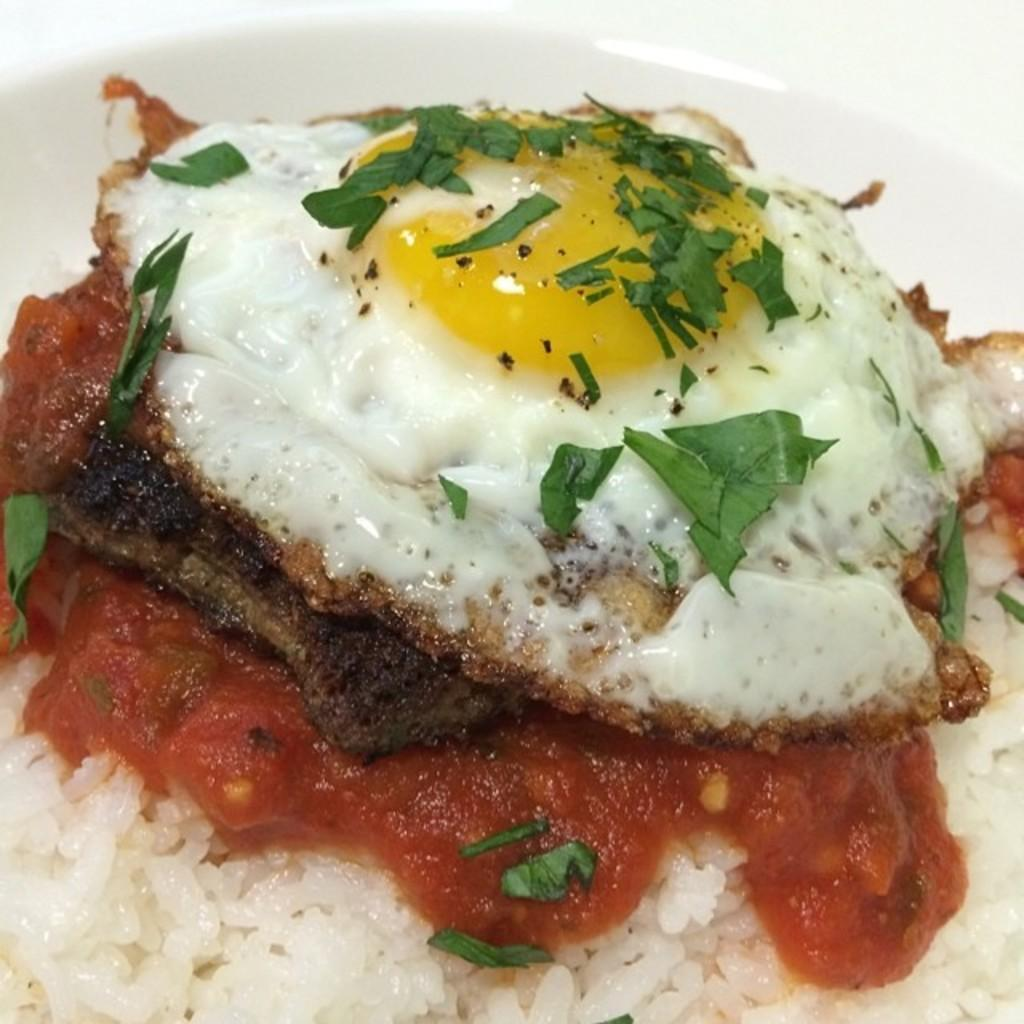What is in the bowl that is visible in the image? The bowl contains rice, omelet, and leafy vegetables. What color is the bowl in the image? The bowl is white in color. What type of needle is being used to write on the brake in the image? There is no needle, writing, or brake present in the image. 